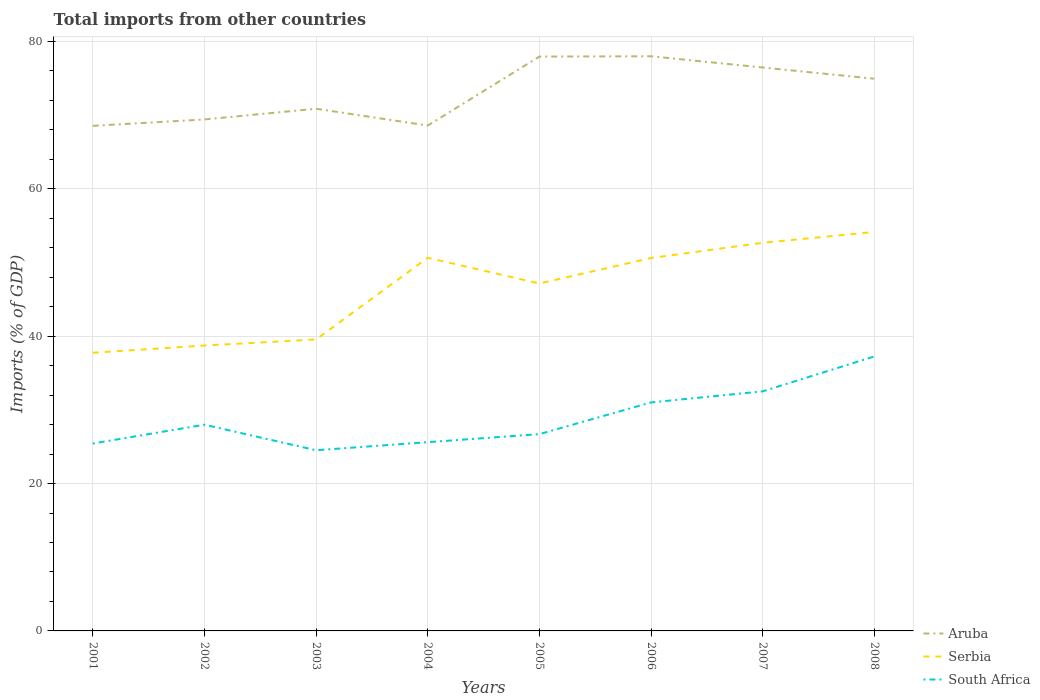Does the line corresponding to Aruba intersect with the line corresponding to South Africa?
Your answer should be compact. No. Is the number of lines equal to the number of legend labels?
Provide a succinct answer. Yes. Across all years, what is the maximum total imports in Serbia?
Give a very brief answer. 37.74. In which year was the total imports in Aruba maximum?
Your answer should be compact. 2001. What is the total total imports in South Africa in the graph?
Ensure brevity in your answer.  -11.82. What is the difference between the highest and the second highest total imports in Serbia?
Ensure brevity in your answer.  16.4. How many years are there in the graph?
Provide a short and direct response. 8. Are the values on the major ticks of Y-axis written in scientific E-notation?
Your response must be concise. No. Does the graph contain any zero values?
Your answer should be very brief. No. Does the graph contain grids?
Provide a succinct answer. Yes. What is the title of the graph?
Give a very brief answer. Total imports from other countries. Does "Switzerland" appear as one of the legend labels in the graph?
Offer a terse response. No. What is the label or title of the X-axis?
Offer a very short reply. Years. What is the label or title of the Y-axis?
Offer a very short reply. Imports (% of GDP). What is the Imports (% of GDP) in Aruba in 2001?
Your response must be concise. 68.53. What is the Imports (% of GDP) of Serbia in 2001?
Your answer should be very brief. 37.74. What is the Imports (% of GDP) of South Africa in 2001?
Ensure brevity in your answer.  25.43. What is the Imports (% of GDP) of Aruba in 2002?
Give a very brief answer. 69.4. What is the Imports (% of GDP) of Serbia in 2002?
Your answer should be very brief. 38.73. What is the Imports (% of GDP) of South Africa in 2002?
Provide a succinct answer. 27.98. What is the Imports (% of GDP) of Aruba in 2003?
Your answer should be compact. 70.85. What is the Imports (% of GDP) in Serbia in 2003?
Provide a short and direct response. 39.55. What is the Imports (% of GDP) in South Africa in 2003?
Make the answer very short. 24.52. What is the Imports (% of GDP) in Aruba in 2004?
Your answer should be compact. 68.57. What is the Imports (% of GDP) of Serbia in 2004?
Provide a succinct answer. 50.63. What is the Imports (% of GDP) of South Africa in 2004?
Keep it short and to the point. 25.61. What is the Imports (% of GDP) of Aruba in 2005?
Make the answer very short. 77.93. What is the Imports (% of GDP) of Serbia in 2005?
Offer a very short reply. 47.14. What is the Imports (% of GDP) in South Africa in 2005?
Your answer should be very brief. 26.7. What is the Imports (% of GDP) in Aruba in 2006?
Provide a short and direct response. 77.97. What is the Imports (% of GDP) of Serbia in 2006?
Your answer should be compact. 50.6. What is the Imports (% of GDP) in South Africa in 2006?
Make the answer very short. 31. What is the Imports (% of GDP) in Aruba in 2007?
Offer a very short reply. 76.45. What is the Imports (% of GDP) of Serbia in 2007?
Your response must be concise. 52.66. What is the Imports (% of GDP) of South Africa in 2007?
Provide a short and direct response. 32.51. What is the Imports (% of GDP) of Aruba in 2008?
Your response must be concise. 74.93. What is the Imports (% of GDP) of Serbia in 2008?
Offer a very short reply. 54.14. What is the Imports (% of GDP) in South Africa in 2008?
Ensure brevity in your answer.  37.24. Across all years, what is the maximum Imports (% of GDP) in Aruba?
Offer a very short reply. 77.97. Across all years, what is the maximum Imports (% of GDP) of Serbia?
Keep it short and to the point. 54.14. Across all years, what is the maximum Imports (% of GDP) in South Africa?
Your answer should be compact. 37.24. Across all years, what is the minimum Imports (% of GDP) in Aruba?
Keep it short and to the point. 68.53. Across all years, what is the minimum Imports (% of GDP) in Serbia?
Provide a short and direct response. 37.74. Across all years, what is the minimum Imports (% of GDP) in South Africa?
Your answer should be compact. 24.52. What is the total Imports (% of GDP) in Aruba in the graph?
Your answer should be very brief. 584.64. What is the total Imports (% of GDP) of Serbia in the graph?
Give a very brief answer. 371.19. What is the total Imports (% of GDP) in South Africa in the graph?
Keep it short and to the point. 231. What is the difference between the Imports (% of GDP) in Aruba in 2001 and that in 2002?
Ensure brevity in your answer.  -0.87. What is the difference between the Imports (% of GDP) in Serbia in 2001 and that in 2002?
Keep it short and to the point. -0.98. What is the difference between the Imports (% of GDP) of South Africa in 2001 and that in 2002?
Your answer should be compact. -2.56. What is the difference between the Imports (% of GDP) of Aruba in 2001 and that in 2003?
Ensure brevity in your answer.  -2.32. What is the difference between the Imports (% of GDP) in Serbia in 2001 and that in 2003?
Ensure brevity in your answer.  -1.81. What is the difference between the Imports (% of GDP) of South Africa in 2001 and that in 2003?
Give a very brief answer. 0.91. What is the difference between the Imports (% of GDP) of Aruba in 2001 and that in 2004?
Your response must be concise. -0.04. What is the difference between the Imports (% of GDP) in Serbia in 2001 and that in 2004?
Provide a succinct answer. -12.89. What is the difference between the Imports (% of GDP) in South Africa in 2001 and that in 2004?
Your answer should be compact. -0.18. What is the difference between the Imports (% of GDP) of Aruba in 2001 and that in 2005?
Your answer should be very brief. -9.4. What is the difference between the Imports (% of GDP) of Serbia in 2001 and that in 2005?
Your response must be concise. -9.4. What is the difference between the Imports (% of GDP) of South Africa in 2001 and that in 2005?
Make the answer very short. -1.28. What is the difference between the Imports (% of GDP) in Aruba in 2001 and that in 2006?
Your answer should be very brief. -9.44. What is the difference between the Imports (% of GDP) of Serbia in 2001 and that in 2006?
Offer a terse response. -12.86. What is the difference between the Imports (% of GDP) of South Africa in 2001 and that in 2006?
Provide a short and direct response. -5.58. What is the difference between the Imports (% of GDP) of Aruba in 2001 and that in 2007?
Provide a succinct answer. -7.92. What is the difference between the Imports (% of GDP) of Serbia in 2001 and that in 2007?
Your answer should be very brief. -14.92. What is the difference between the Imports (% of GDP) of South Africa in 2001 and that in 2007?
Provide a succinct answer. -7.08. What is the difference between the Imports (% of GDP) in Aruba in 2001 and that in 2008?
Offer a terse response. -6.39. What is the difference between the Imports (% of GDP) of Serbia in 2001 and that in 2008?
Offer a terse response. -16.4. What is the difference between the Imports (% of GDP) in South Africa in 2001 and that in 2008?
Ensure brevity in your answer.  -11.82. What is the difference between the Imports (% of GDP) in Aruba in 2002 and that in 2003?
Give a very brief answer. -1.45. What is the difference between the Imports (% of GDP) in Serbia in 2002 and that in 2003?
Provide a short and direct response. -0.83. What is the difference between the Imports (% of GDP) of South Africa in 2002 and that in 2003?
Keep it short and to the point. 3.47. What is the difference between the Imports (% of GDP) in Aruba in 2002 and that in 2004?
Provide a short and direct response. 0.83. What is the difference between the Imports (% of GDP) in Serbia in 2002 and that in 2004?
Your answer should be compact. -11.91. What is the difference between the Imports (% of GDP) in South Africa in 2002 and that in 2004?
Your response must be concise. 2.37. What is the difference between the Imports (% of GDP) in Aruba in 2002 and that in 2005?
Offer a terse response. -8.53. What is the difference between the Imports (% of GDP) in Serbia in 2002 and that in 2005?
Your response must be concise. -8.41. What is the difference between the Imports (% of GDP) in South Africa in 2002 and that in 2005?
Your answer should be compact. 1.28. What is the difference between the Imports (% of GDP) of Aruba in 2002 and that in 2006?
Give a very brief answer. -8.57. What is the difference between the Imports (% of GDP) in Serbia in 2002 and that in 2006?
Give a very brief answer. -11.87. What is the difference between the Imports (% of GDP) of South Africa in 2002 and that in 2006?
Ensure brevity in your answer.  -3.02. What is the difference between the Imports (% of GDP) in Aruba in 2002 and that in 2007?
Your response must be concise. -7.05. What is the difference between the Imports (% of GDP) of Serbia in 2002 and that in 2007?
Ensure brevity in your answer.  -13.94. What is the difference between the Imports (% of GDP) in South Africa in 2002 and that in 2007?
Provide a succinct answer. -4.53. What is the difference between the Imports (% of GDP) in Aruba in 2002 and that in 2008?
Offer a very short reply. -5.53. What is the difference between the Imports (% of GDP) in Serbia in 2002 and that in 2008?
Your response must be concise. -15.41. What is the difference between the Imports (% of GDP) of South Africa in 2002 and that in 2008?
Offer a terse response. -9.26. What is the difference between the Imports (% of GDP) in Aruba in 2003 and that in 2004?
Ensure brevity in your answer.  2.28. What is the difference between the Imports (% of GDP) in Serbia in 2003 and that in 2004?
Make the answer very short. -11.08. What is the difference between the Imports (% of GDP) of South Africa in 2003 and that in 2004?
Your answer should be compact. -1.09. What is the difference between the Imports (% of GDP) in Aruba in 2003 and that in 2005?
Give a very brief answer. -7.08. What is the difference between the Imports (% of GDP) of Serbia in 2003 and that in 2005?
Offer a very short reply. -7.59. What is the difference between the Imports (% of GDP) in South Africa in 2003 and that in 2005?
Provide a succinct answer. -2.19. What is the difference between the Imports (% of GDP) of Aruba in 2003 and that in 2006?
Ensure brevity in your answer.  -7.12. What is the difference between the Imports (% of GDP) of Serbia in 2003 and that in 2006?
Provide a succinct answer. -11.05. What is the difference between the Imports (% of GDP) in South Africa in 2003 and that in 2006?
Provide a succinct answer. -6.49. What is the difference between the Imports (% of GDP) of Aruba in 2003 and that in 2007?
Your response must be concise. -5.6. What is the difference between the Imports (% of GDP) of Serbia in 2003 and that in 2007?
Your answer should be very brief. -13.11. What is the difference between the Imports (% of GDP) in South Africa in 2003 and that in 2007?
Provide a succinct answer. -7.99. What is the difference between the Imports (% of GDP) in Aruba in 2003 and that in 2008?
Give a very brief answer. -4.07. What is the difference between the Imports (% of GDP) of Serbia in 2003 and that in 2008?
Make the answer very short. -14.59. What is the difference between the Imports (% of GDP) in South Africa in 2003 and that in 2008?
Provide a succinct answer. -12.73. What is the difference between the Imports (% of GDP) in Aruba in 2004 and that in 2005?
Give a very brief answer. -9.36. What is the difference between the Imports (% of GDP) in Serbia in 2004 and that in 2005?
Offer a terse response. 3.49. What is the difference between the Imports (% of GDP) of South Africa in 2004 and that in 2005?
Your response must be concise. -1.09. What is the difference between the Imports (% of GDP) in Aruba in 2004 and that in 2006?
Provide a succinct answer. -9.4. What is the difference between the Imports (% of GDP) in Serbia in 2004 and that in 2006?
Your response must be concise. 0.03. What is the difference between the Imports (% of GDP) in South Africa in 2004 and that in 2006?
Offer a terse response. -5.39. What is the difference between the Imports (% of GDP) of Aruba in 2004 and that in 2007?
Give a very brief answer. -7.88. What is the difference between the Imports (% of GDP) in Serbia in 2004 and that in 2007?
Offer a very short reply. -2.03. What is the difference between the Imports (% of GDP) of South Africa in 2004 and that in 2007?
Provide a short and direct response. -6.9. What is the difference between the Imports (% of GDP) of Aruba in 2004 and that in 2008?
Make the answer very short. -6.35. What is the difference between the Imports (% of GDP) in Serbia in 2004 and that in 2008?
Make the answer very short. -3.51. What is the difference between the Imports (% of GDP) in South Africa in 2004 and that in 2008?
Your answer should be compact. -11.63. What is the difference between the Imports (% of GDP) in Aruba in 2005 and that in 2006?
Keep it short and to the point. -0.04. What is the difference between the Imports (% of GDP) in Serbia in 2005 and that in 2006?
Offer a very short reply. -3.46. What is the difference between the Imports (% of GDP) of South Africa in 2005 and that in 2006?
Keep it short and to the point. -4.3. What is the difference between the Imports (% of GDP) in Aruba in 2005 and that in 2007?
Give a very brief answer. 1.48. What is the difference between the Imports (% of GDP) in Serbia in 2005 and that in 2007?
Provide a short and direct response. -5.52. What is the difference between the Imports (% of GDP) of South Africa in 2005 and that in 2007?
Provide a succinct answer. -5.81. What is the difference between the Imports (% of GDP) of Aruba in 2005 and that in 2008?
Ensure brevity in your answer.  3.01. What is the difference between the Imports (% of GDP) of Serbia in 2005 and that in 2008?
Give a very brief answer. -7. What is the difference between the Imports (% of GDP) of South Africa in 2005 and that in 2008?
Your answer should be very brief. -10.54. What is the difference between the Imports (% of GDP) in Aruba in 2006 and that in 2007?
Your response must be concise. 1.52. What is the difference between the Imports (% of GDP) of Serbia in 2006 and that in 2007?
Give a very brief answer. -2.06. What is the difference between the Imports (% of GDP) in South Africa in 2006 and that in 2007?
Keep it short and to the point. -1.51. What is the difference between the Imports (% of GDP) of Aruba in 2006 and that in 2008?
Keep it short and to the point. 3.05. What is the difference between the Imports (% of GDP) in Serbia in 2006 and that in 2008?
Provide a short and direct response. -3.54. What is the difference between the Imports (% of GDP) of South Africa in 2006 and that in 2008?
Keep it short and to the point. -6.24. What is the difference between the Imports (% of GDP) of Aruba in 2007 and that in 2008?
Offer a terse response. 1.52. What is the difference between the Imports (% of GDP) in Serbia in 2007 and that in 2008?
Provide a succinct answer. -1.48. What is the difference between the Imports (% of GDP) of South Africa in 2007 and that in 2008?
Offer a very short reply. -4.73. What is the difference between the Imports (% of GDP) of Aruba in 2001 and the Imports (% of GDP) of Serbia in 2002?
Provide a succinct answer. 29.81. What is the difference between the Imports (% of GDP) of Aruba in 2001 and the Imports (% of GDP) of South Africa in 2002?
Ensure brevity in your answer.  40.55. What is the difference between the Imports (% of GDP) of Serbia in 2001 and the Imports (% of GDP) of South Africa in 2002?
Your response must be concise. 9.76. What is the difference between the Imports (% of GDP) of Aruba in 2001 and the Imports (% of GDP) of Serbia in 2003?
Your answer should be compact. 28.98. What is the difference between the Imports (% of GDP) of Aruba in 2001 and the Imports (% of GDP) of South Africa in 2003?
Offer a very short reply. 44.02. What is the difference between the Imports (% of GDP) of Serbia in 2001 and the Imports (% of GDP) of South Africa in 2003?
Your answer should be very brief. 13.23. What is the difference between the Imports (% of GDP) in Aruba in 2001 and the Imports (% of GDP) in Serbia in 2004?
Make the answer very short. 17.9. What is the difference between the Imports (% of GDP) in Aruba in 2001 and the Imports (% of GDP) in South Africa in 2004?
Your response must be concise. 42.92. What is the difference between the Imports (% of GDP) in Serbia in 2001 and the Imports (% of GDP) in South Africa in 2004?
Provide a short and direct response. 12.13. What is the difference between the Imports (% of GDP) of Aruba in 2001 and the Imports (% of GDP) of Serbia in 2005?
Offer a very short reply. 21.39. What is the difference between the Imports (% of GDP) in Aruba in 2001 and the Imports (% of GDP) in South Africa in 2005?
Make the answer very short. 41.83. What is the difference between the Imports (% of GDP) of Serbia in 2001 and the Imports (% of GDP) of South Africa in 2005?
Ensure brevity in your answer.  11.04. What is the difference between the Imports (% of GDP) in Aruba in 2001 and the Imports (% of GDP) in Serbia in 2006?
Offer a terse response. 17.93. What is the difference between the Imports (% of GDP) of Aruba in 2001 and the Imports (% of GDP) of South Africa in 2006?
Make the answer very short. 37.53. What is the difference between the Imports (% of GDP) of Serbia in 2001 and the Imports (% of GDP) of South Africa in 2006?
Offer a terse response. 6.74. What is the difference between the Imports (% of GDP) of Aruba in 2001 and the Imports (% of GDP) of Serbia in 2007?
Ensure brevity in your answer.  15.87. What is the difference between the Imports (% of GDP) of Aruba in 2001 and the Imports (% of GDP) of South Africa in 2007?
Your response must be concise. 36.02. What is the difference between the Imports (% of GDP) in Serbia in 2001 and the Imports (% of GDP) in South Africa in 2007?
Provide a short and direct response. 5.23. What is the difference between the Imports (% of GDP) in Aruba in 2001 and the Imports (% of GDP) in Serbia in 2008?
Offer a terse response. 14.4. What is the difference between the Imports (% of GDP) in Aruba in 2001 and the Imports (% of GDP) in South Africa in 2008?
Ensure brevity in your answer.  31.29. What is the difference between the Imports (% of GDP) in Serbia in 2001 and the Imports (% of GDP) in South Africa in 2008?
Provide a short and direct response. 0.5. What is the difference between the Imports (% of GDP) in Aruba in 2002 and the Imports (% of GDP) in Serbia in 2003?
Ensure brevity in your answer.  29.85. What is the difference between the Imports (% of GDP) of Aruba in 2002 and the Imports (% of GDP) of South Africa in 2003?
Your answer should be very brief. 44.88. What is the difference between the Imports (% of GDP) of Serbia in 2002 and the Imports (% of GDP) of South Africa in 2003?
Give a very brief answer. 14.21. What is the difference between the Imports (% of GDP) of Aruba in 2002 and the Imports (% of GDP) of Serbia in 2004?
Your response must be concise. 18.77. What is the difference between the Imports (% of GDP) in Aruba in 2002 and the Imports (% of GDP) in South Africa in 2004?
Provide a short and direct response. 43.79. What is the difference between the Imports (% of GDP) in Serbia in 2002 and the Imports (% of GDP) in South Africa in 2004?
Make the answer very short. 13.11. What is the difference between the Imports (% of GDP) of Aruba in 2002 and the Imports (% of GDP) of Serbia in 2005?
Ensure brevity in your answer.  22.26. What is the difference between the Imports (% of GDP) of Aruba in 2002 and the Imports (% of GDP) of South Africa in 2005?
Provide a short and direct response. 42.7. What is the difference between the Imports (% of GDP) in Serbia in 2002 and the Imports (% of GDP) in South Africa in 2005?
Keep it short and to the point. 12.02. What is the difference between the Imports (% of GDP) of Aruba in 2002 and the Imports (% of GDP) of Serbia in 2006?
Keep it short and to the point. 18.8. What is the difference between the Imports (% of GDP) in Aruba in 2002 and the Imports (% of GDP) in South Africa in 2006?
Keep it short and to the point. 38.4. What is the difference between the Imports (% of GDP) in Serbia in 2002 and the Imports (% of GDP) in South Africa in 2006?
Give a very brief answer. 7.72. What is the difference between the Imports (% of GDP) of Aruba in 2002 and the Imports (% of GDP) of Serbia in 2007?
Keep it short and to the point. 16.74. What is the difference between the Imports (% of GDP) of Aruba in 2002 and the Imports (% of GDP) of South Africa in 2007?
Your answer should be compact. 36.89. What is the difference between the Imports (% of GDP) in Serbia in 2002 and the Imports (% of GDP) in South Africa in 2007?
Provide a succinct answer. 6.22. What is the difference between the Imports (% of GDP) of Aruba in 2002 and the Imports (% of GDP) of Serbia in 2008?
Ensure brevity in your answer.  15.26. What is the difference between the Imports (% of GDP) in Aruba in 2002 and the Imports (% of GDP) in South Africa in 2008?
Ensure brevity in your answer.  32.16. What is the difference between the Imports (% of GDP) of Serbia in 2002 and the Imports (% of GDP) of South Africa in 2008?
Make the answer very short. 1.48. What is the difference between the Imports (% of GDP) in Aruba in 2003 and the Imports (% of GDP) in Serbia in 2004?
Ensure brevity in your answer.  20.22. What is the difference between the Imports (% of GDP) of Aruba in 2003 and the Imports (% of GDP) of South Africa in 2004?
Offer a very short reply. 45.24. What is the difference between the Imports (% of GDP) in Serbia in 2003 and the Imports (% of GDP) in South Africa in 2004?
Make the answer very short. 13.94. What is the difference between the Imports (% of GDP) of Aruba in 2003 and the Imports (% of GDP) of Serbia in 2005?
Offer a terse response. 23.71. What is the difference between the Imports (% of GDP) of Aruba in 2003 and the Imports (% of GDP) of South Africa in 2005?
Ensure brevity in your answer.  44.15. What is the difference between the Imports (% of GDP) in Serbia in 2003 and the Imports (% of GDP) in South Africa in 2005?
Offer a terse response. 12.85. What is the difference between the Imports (% of GDP) in Aruba in 2003 and the Imports (% of GDP) in Serbia in 2006?
Offer a very short reply. 20.25. What is the difference between the Imports (% of GDP) of Aruba in 2003 and the Imports (% of GDP) of South Africa in 2006?
Make the answer very short. 39.85. What is the difference between the Imports (% of GDP) in Serbia in 2003 and the Imports (% of GDP) in South Africa in 2006?
Your response must be concise. 8.55. What is the difference between the Imports (% of GDP) of Aruba in 2003 and the Imports (% of GDP) of Serbia in 2007?
Provide a succinct answer. 18.19. What is the difference between the Imports (% of GDP) of Aruba in 2003 and the Imports (% of GDP) of South Africa in 2007?
Your answer should be very brief. 38.34. What is the difference between the Imports (% of GDP) in Serbia in 2003 and the Imports (% of GDP) in South Africa in 2007?
Give a very brief answer. 7.04. What is the difference between the Imports (% of GDP) of Aruba in 2003 and the Imports (% of GDP) of Serbia in 2008?
Offer a very short reply. 16.71. What is the difference between the Imports (% of GDP) in Aruba in 2003 and the Imports (% of GDP) in South Africa in 2008?
Your answer should be compact. 33.61. What is the difference between the Imports (% of GDP) in Serbia in 2003 and the Imports (% of GDP) in South Africa in 2008?
Offer a very short reply. 2.31. What is the difference between the Imports (% of GDP) of Aruba in 2004 and the Imports (% of GDP) of Serbia in 2005?
Offer a terse response. 21.43. What is the difference between the Imports (% of GDP) of Aruba in 2004 and the Imports (% of GDP) of South Africa in 2005?
Offer a terse response. 41.87. What is the difference between the Imports (% of GDP) in Serbia in 2004 and the Imports (% of GDP) in South Africa in 2005?
Offer a terse response. 23.93. What is the difference between the Imports (% of GDP) of Aruba in 2004 and the Imports (% of GDP) of Serbia in 2006?
Give a very brief answer. 17.97. What is the difference between the Imports (% of GDP) of Aruba in 2004 and the Imports (% of GDP) of South Africa in 2006?
Your answer should be very brief. 37.57. What is the difference between the Imports (% of GDP) of Serbia in 2004 and the Imports (% of GDP) of South Africa in 2006?
Make the answer very short. 19.63. What is the difference between the Imports (% of GDP) of Aruba in 2004 and the Imports (% of GDP) of Serbia in 2007?
Your response must be concise. 15.91. What is the difference between the Imports (% of GDP) in Aruba in 2004 and the Imports (% of GDP) in South Africa in 2007?
Keep it short and to the point. 36.06. What is the difference between the Imports (% of GDP) of Serbia in 2004 and the Imports (% of GDP) of South Africa in 2007?
Offer a terse response. 18.12. What is the difference between the Imports (% of GDP) in Aruba in 2004 and the Imports (% of GDP) in Serbia in 2008?
Your answer should be very brief. 14.43. What is the difference between the Imports (% of GDP) in Aruba in 2004 and the Imports (% of GDP) in South Africa in 2008?
Keep it short and to the point. 31.33. What is the difference between the Imports (% of GDP) of Serbia in 2004 and the Imports (% of GDP) of South Africa in 2008?
Your response must be concise. 13.39. What is the difference between the Imports (% of GDP) of Aruba in 2005 and the Imports (% of GDP) of Serbia in 2006?
Keep it short and to the point. 27.33. What is the difference between the Imports (% of GDP) of Aruba in 2005 and the Imports (% of GDP) of South Africa in 2006?
Ensure brevity in your answer.  46.93. What is the difference between the Imports (% of GDP) of Serbia in 2005 and the Imports (% of GDP) of South Africa in 2006?
Give a very brief answer. 16.14. What is the difference between the Imports (% of GDP) of Aruba in 2005 and the Imports (% of GDP) of Serbia in 2007?
Offer a very short reply. 25.27. What is the difference between the Imports (% of GDP) of Aruba in 2005 and the Imports (% of GDP) of South Africa in 2007?
Offer a very short reply. 45.42. What is the difference between the Imports (% of GDP) in Serbia in 2005 and the Imports (% of GDP) in South Africa in 2007?
Make the answer very short. 14.63. What is the difference between the Imports (% of GDP) of Aruba in 2005 and the Imports (% of GDP) of Serbia in 2008?
Give a very brief answer. 23.79. What is the difference between the Imports (% of GDP) of Aruba in 2005 and the Imports (% of GDP) of South Africa in 2008?
Your answer should be compact. 40.69. What is the difference between the Imports (% of GDP) in Serbia in 2005 and the Imports (% of GDP) in South Africa in 2008?
Offer a terse response. 9.9. What is the difference between the Imports (% of GDP) in Aruba in 2006 and the Imports (% of GDP) in Serbia in 2007?
Your answer should be compact. 25.31. What is the difference between the Imports (% of GDP) of Aruba in 2006 and the Imports (% of GDP) of South Africa in 2007?
Provide a succinct answer. 45.46. What is the difference between the Imports (% of GDP) in Serbia in 2006 and the Imports (% of GDP) in South Africa in 2007?
Your response must be concise. 18.09. What is the difference between the Imports (% of GDP) in Aruba in 2006 and the Imports (% of GDP) in Serbia in 2008?
Provide a succinct answer. 23.83. What is the difference between the Imports (% of GDP) of Aruba in 2006 and the Imports (% of GDP) of South Africa in 2008?
Your response must be concise. 40.73. What is the difference between the Imports (% of GDP) in Serbia in 2006 and the Imports (% of GDP) in South Africa in 2008?
Give a very brief answer. 13.36. What is the difference between the Imports (% of GDP) in Aruba in 2007 and the Imports (% of GDP) in Serbia in 2008?
Your answer should be very brief. 22.31. What is the difference between the Imports (% of GDP) in Aruba in 2007 and the Imports (% of GDP) in South Africa in 2008?
Offer a very short reply. 39.21. What is the difference between the Imports (% of GDP) of Serbia in 2007 and the Imports (% of GDP) of South Africa in 2008?
Keep it short and to the point. 15.42. What is the average Imports (% of GDP) of Aruba per year?
Give a very brief answer. 73.08. What is the average Imports (% of GDP) of Serbia per year?
Provide a succinct answer. 46.4. What is the average Imports (% of GDP) in South Africa per year?
Your answer should be very brief. 28.87. In the year 2001, what is the difference between the Imports (% of GDP) in Aruba and Imports (% of GDP) in Serbia?
Make the answer very short. 30.79. In the year 2001, what is the difference between the Imports (% of GDP) in Aruba and Imports (% of GDP) in South Africa?
Ensure brevity in your answer.  43.11. In the year 2001, what is the difference between the Imports (% of GDP) in Serbia and Imports (% of GDP) in South Africa?
Your answer should be compact. 12.32. In the year 2002, what is the difference between the Imports (% of GDP) of Aruba and Imports (% of GDP) of Serbia?
Your answer should be very brief. 30.68. In the year 2002, what is the difference between the Imports (% of GDP) in Aruba and Imports (% of GDP) in South Africa?
Offer a very short reply. 41.42. In the year 2002, what is the difference between the Imports (% of GDP) of Serbia and Imports (% of GDP) of South Africa?
Make the answer very short. 10.74. In the year 2003, what is the difference between the Imports (% of GDP) in Aruba and Imports (% of GDP) in Serbia?
Offer a terse response. 31.3. In the year 2003, what is the difference between the Imports (% of GDP) in Aruba and Imports (% of GDP) in South Africa?
Your response must be concise. 46.34. In the year 2003, what is the difference between the Imports (% of GDP) in Serbia and Imports (% of GDP) in South Africa?
Keep it short and to the point. 15.03. In the year 2004, what is the difference between the Imports (% of GDP) in Aruba and Imports (% of GDP) in Serbia?
Your response must be concise. 17.94. In the year 2004, what is the difference between the Imports (% of GDP) in Aruba and Imports (% of GDP) in South Africa?
Ensure brevity in your answer.  42.96. In the year 2004, what is the difference between the Imports (% of GDP) of Serbia and Imports (% of GDP) of South Africa?
Give a very brief answer. 25.02. In the year 2005, what is the difference between the Imports (% of GDP) of Aruba and Imports (% of GDP) of Serbia?
Your response must be concise. 30.79. In the year 2005, what is the difference between the Imports (% of GDP) of Aruba and Imports (% of GDP) of South Africa?
Offer a very short reply. 51.23. In the year 2005, what is the difference between the Imports (% of GDP) of Serbia and Imports (% of GDP) of South Africa?
Your response must be concise. 20.44. In the year 2006, what is the difference between the Imports (% of GDP) in Aruba and Imports (% of GDP) in Serbia?
Your answer should be compact. 27.37. In the year 2006, what is the difference between the Imports (% of GDP) in Aruba and Imports (% of GDP) in South Africa?
Make the answer very short. 46.97. In the year 2006, what is the difference between the Imports (% of GDP) of Serbia and Imports (% of GDP) of South Africa?
Your answer should be compact. 19.6. In the year 2007, what is the difference between the Imports (% of GDP) of Aruba and Imports (% of GDP) of Serbia?
Provide a succinct answer. 23.79. In the year 2007, what is the difference between the Imports (% of GDP) in Aruba and Imports (% of GDP) in South Africa?
Ensure brevity in your answer.  43.94. In the year 2007, what is the difference between the Imports (% of GDP) of Serbia and Imports (% of GDP) of South Africa?
Make the answer very short. 20.15. In the year 2008, what is the difference between the Imports (% of GDP) in Aruba and Imports (% of GDP) in Serbia?
Keep it short and to the point. 20.79. In the year 2008, what is the difference between the Imports (% of GDP) of Aruba and Imports (% of GDP) of South Africa?
Offer a terse response. 37.68. In the year 2008, what is the difference between the Imports (% of GDP) in Serbia and Imports (% of GDP) in South Africa?
Your response must be concise. 16.9. What is the ratio of the Imports (% of GDP) in Aruba in 2001 to that in 2002?
Your answer should be very brief. 0.99. What is the ratio of the Imports (% of GDP) in Serbia in 2001 to that in 2002?
Your response must be concise. 0.97. What is the ratio of the Imports (% of GDP) of South Africa in 2001 to that in 2002?
Give a very brief answer. 0.91. What is the ratio of the Imports (% of GDP) of Aruba in 2001 to that in 2003?
Keep it short and to the point. 0.97. What is the ratio of the Imports (% of GDP) in Serbia in 2001 to that in 2003?
Provide a short and direct response. 0.95. What is the ratio of the Imports (% of GDP) of South Africa in 2001 to that in 2003?
Your answer should be very brief. 1.04. What is the ratio of the Imports (% of GDP) of Aruba in 2001 to that in 2004?
Keep it short and to the point. 1. What is the ratio of the Imports (% of GDP) of Serbia in 2001 to that in 2004?
Offer a terse response. 0.75. What is the ratio of the Imports (% of GDP) of South Africa in 2001 to that in 2004?
Provide a short and direct response. 0.99. What is the ratio of the Imports (% of GDP) in Aruba in 2001 to that in 2005?
Ensure brevity in your answer.  0.88. What is the ratio of the Imports (% of GDP) in Serbia in 2001 to that in 2005?
Provide a short and direct response. 0.8. What is the ratio of the Imports (% of GDP) of South Africa in 2001 to that in 2005?
Provide a succinct answer. 0.95. What is the ratio of the Imports (% of GDP) of Aruba in 2001 to that in 2006?
Offer a terse response. 0.88. What is the ratio of the Imports (% of GDP) of Serbia in 2001 to that in 2006?
Ensure brevity in your answer.  0.75. What is the ratio of the Imports (% of GDP) of South Africa in 2001 to that in 2006?
Your answer should be very brief. 0.82. What is the ratio of the Imports (% of GDP) in Aruba in 2001 to that in 2007?
Your answer should be very brief. 0.9. What is the ratio of the Imports (% of GDP) in Serbia in 2001 to that in 2007?
Your response must be concise. 0.72. What is the ratio of the Imports (% of GDP) of South Africa in 2001 to that in 2007?
Keep it short and to the point. 0.78. What is the ratio of the Imports (% of GDP) in Aruba in 2001 to that in 2008?
Offer a very short reply. 0.91. What is the ratio of the Imports (% of GDP) in Serbia in 2001 to that in 2008?
Your response must be concise. 0.7. What is the ratio of the Imports (% of GDP) of South Africa in 2001 to that in 2008?
Offer a terse response. 0.68. What is the ratio of the Imports (% of GDP) in Aruba in 2002 to that in 2003?
Keep it short and to the point. 0.98. What is the ratio of the Imports (% of GDP) of Serbia in 2002 to that in 2003?
Make the answer very short. 0.98. What is the ratio of the Imports (% of GDP) of South Africa in 2002 to that in 2003?
Your answer should be very brief. 1.14. What is the ratio of the Imports (% of GDP) in Aruba in 2002 to that in 2004?
Ensure brevity in your answer.  1.01. What is the ratio of the Imports (% of GDP) in Serbia in 2002 to that in 2004?
Provide a short and direct response. 0.76. What is the ratio of the Imports (% of GDP) in South Africa in 2002 to that in 2004?
Give a very brief answer. 1.09. What is the ratio of the Imports (% of GDP) of Aruba in 2002 to that in 2005?
Your answer should be compact. 0.89. What is the ratio of the Imports (% of GDP) of Serbia in 2002 to that in 2005?
Keep it short and to the point. 0.82. What is the ratio of the Imports (% of GDP) of South Africa in 2002 to that in 2005?
Your answer should be very brief. 1.05. What is the ratio of the Imports (% of GDP) of Aruba in 2002 to that in 2006?
Offer a terse response. 0.89. What is the ratio of the Imports (% of GDP) of Serbia in 2002 to that in 2006?
Offer a very short reply. 0.77. What is the ratio of the Imports (% of GDP) in South Africa in 2002 to that in 2006?
Your response must be concise. 0.9. What is the ratio of the Imports (% of GDP) of Aruba in 2002 to that in 2007?
Your answer should be very brief. 0.91. What is the ratio of the Imports (% of GDP) in Serbia in 2002 to that in 2007?
Your response must be concise. 0.74. What is the ratio of the Imports (% of GDP) of South Africa in 2002 to that in 2007?
Your answer should be compact. 0.86. What is the ratio of the Imports (% of GDP) of Aruba in 2002 to that in 2008?
Ensure brevity in your answer.  0.93. What is the ratio of the Imports (% of GDP) in Serbia in 2002 to that in 2008?
Give a very brief answer. 0.72. What is the ratio of the Imports (% of GDP) of South Africa in 2002 to that in 2008?
Offer a very short reply. 0.75. What is the ratio of the Imports (% of GDP) in Serbia in 2003 to that in 2004?
Ensure brevity in your answer.  0.78. What is the ratio of the Imports (% of GDP) of South Africa in 2003 to that in 2004?
Your answer should be very brief. 0.96. What is the ratio of the Imports (% of GDP) of Aruba in 2003 to that in 2005?
Provide a succinct answer. 0.91. What is the ratio of the Imports (% of GDP) of Serbia in 2003 to that in 2005?
Offer a very short reply. 0.84. What is the ratio of the Imports (% of GDP) of South Africa in 2003 to that in 2005?
Your response must be concise. 0.92. What is the ratio of the Imports (% of GDP) of Aruba in 2003 to that in 2006?
Provide a succinct answer. 0.91. What is the ratio of the Imports (% of GDP) in Serbia in 2003 to that in 2006?
Offer a terse response. 0.78. What is the ratio of the Imports (% of GDP) of South Africa in 2003 to that in 2006?
Your response must be concise. 0.79. What is the ratio of the Imports (% of GDP) of Aruba in 2003 to that in 2007?
Your response must be concise. 0.93. What is the ratio of the Imports (% of GDP) in Serbia in 2003 to that in 2007?
Provide a succinct answer. 0.75. What is the ratio of the Imports (% of GDP) of South Africa in 2003 to that in 2007?
Your answer should be very brief. 0.75. What is the ratio of the Imports (% of GDP) of Aruba in 2003 to that in 2008?
Offer a very short reply. 0.95. What is the ratio of the Imports (% of GDP) in Serbia in 2003 to that in 2008?
Offer a terse response. 0.73. What is the ratio of the Imports (% of GDP) in South Africa in 2003 to that in 2008?
Make the answer very short. 0.66. What is the ratio of the Imports (% of GDP) of Aruba in 2004 to that in 2005?
Your response must be concise. 0.88. What is the ratio of the Imports (% of GDP) of Serbia in 2004 to that in 2005?
Your answer should be very brief. 1.07. What is the ratio of the Imports (% of GDP) of South Africa in 2004 to that in 2005?
Provide a short and direct response. 0.96. What is the ratio of the Imports (% of GDP) of Aruba in 2004 to that in 2006?
Offer a terse response. 0.88. What is the ratio of the Imports (% of GDP) in Serbia in 2004 to that in 2006?
Provide a short and direct response. 1. What is the ratio of the Imports (% of GDP) of South Africa in 2004 to that in 2006?
Ensure brevity in your answer.  0.83. What is the ratio of the Imports (% of GDP) of Aruba in 2004 to that in 2007?
Your answer should be compact. 0.9. What is the ratio of the Imports (% of GDP) in Serbia in 2004 to that in 2007?
Keep it short and to the point. 0.96. What is the ratio of the Imports (% of GDP) in South Africa in 2004 to that in 2007?
Offer a terse response. 0.79. What is the ratio of the Imports (% of GDP) of Aruba in 2004 to that in 2008?
Ensure brevity in your answer.  0.92. What is the ratio of the Imports (% of GDP) in Serbia in 2004 to that in 2008?
Provide a succinct answer. 0.94. What is the ratio of the Imports (% of GDP) in South Africa in 2004 to that in 2008?
Give a very brief answer. 0.69. What is the ratio of the Imports (% of GDP) in Serbia in 2005 to that in 2006?
Keep it short and to the point. 0.93. What is the ratio of the Imports (% of GDP) in South Africa in 2005 to that in 2006?
Your answer should be very brief. 0.86. What is the ratio of the Imports (% of GDP) of Aruba in 2005 to that in 2007?
Offer a terse response. 1.02. What is the ratio of the Imports (% of GDP) of Serbia in 2005 to that in 2007?
Provide a succinct answer. 0.9. What is the ratio of the Imports (% of GDP) of South Africa in 2005 to that in 2007?
Provide a succinct answer. 0.82. What is the ratio of the Imports (% of GDP) in Aruba in 2005 to that in 2008?
Make the answer very short. 1.04. What is the ratio of the Imports (% of GDP) of Serbia in 2005 to that in 2008?
Give a very brief answer. 0.87. What is the ratio of the Imports (% of GDP) in South Africa in 2005 to that in 2008?
Ensure brevity in your answer.  0.72. What is the ratio of the Imports (% of GDP) of Aruba in 2006 to that in 2007?
Offer a terse response. 1.02. What is the ratio of the Imports (% of GDP) of Serbia in 2006 to that in 2007?
Offer a very short reply. 0.96. What is the ratio of the Imports (% of GDP) in South Africa in 2006 to that in 2007?
Your response must be concise. 0.95. What is the ratio of the Imports (% of GDP) of Aruba in 2006 to that in 2008?
Offer a very short reply. 1.04. What is the ratio of the Imports (% of GDP) in Serbia in 2006 to that in 2008?
Your response must be concise. 0.93. What is the ratio of the Imports (% of GDP) in South Africa in 2006 to that in 2008?
Your answer should be very brief. 0.83. What is the ratio of the Imports (% of GDP) of Aruba in 2007 to that in 2008?
Your answer should be compact. 1.02. What is the ratio of the Imports (% of GDP) of Serbia in 2007 to that in 2008?
Your response must be concise. 0.97. What is the ratio of the Imports (% of GDP) in South Africa in 2007 to that in 2008?
Make the answer very short. 0.87. What is the difference between the highest and the second highest Imports (% of GDP) of Aruba?
Provide a succinct answer. 0.04. What is the difference between the highest and the second highest Imports (% of GDP) in Serbia?
Provide a short and direct response. 1.48. What is the difference between the highest and the second highest Imports (% of GDP) in South Africa?
Make the answer very short. 4.73. What is the difference between the highest and the lowest Imports (% of GDP) in Aruba?
Offer a terse response. 9.44. What is the difference between the highest and the lowest Imports (% of GDP) of Serbia?
Provide a short and direct response. 16.4. What is the difference between the highest and the lowest Imports (% of GDP) of South Africa?
Your response must be concise. 12.73. 